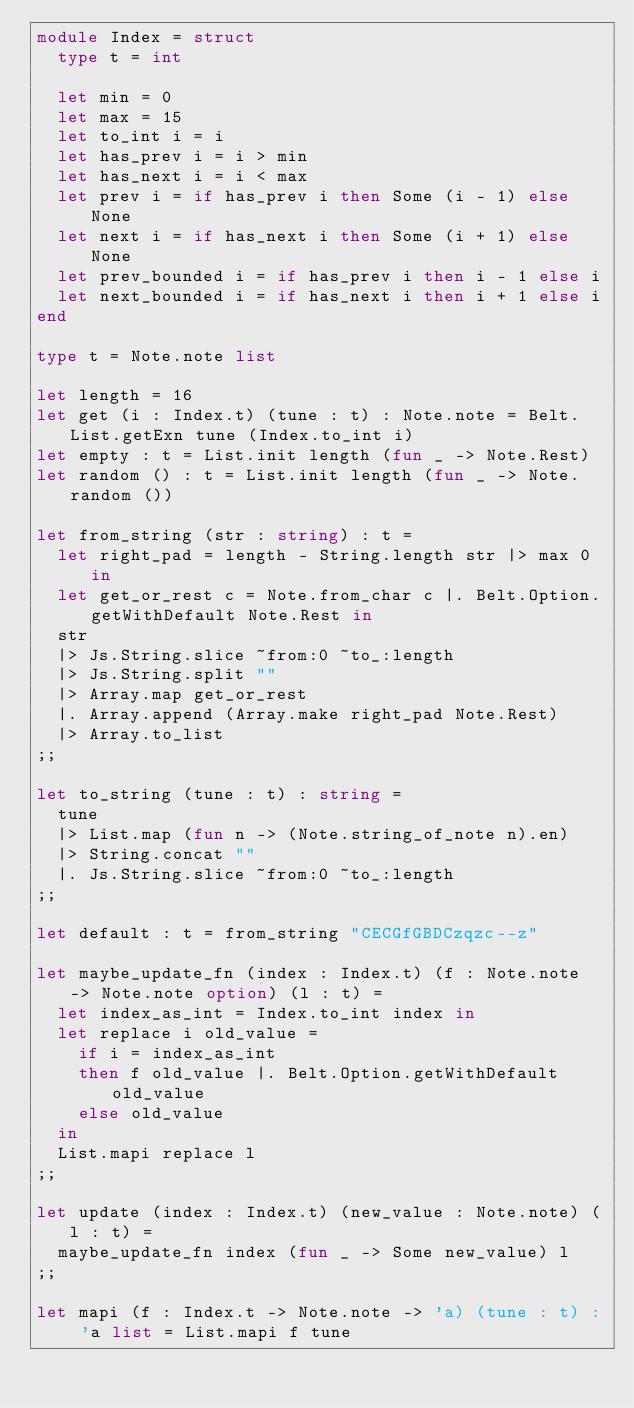Convert code to text. <code><loc_0><loc_0><loc_500><loc_500><_OCaml_>module Index = struct
  type t = int

  let min = 0
  let max = 15
  let to_int i = i
  let has_prev i = i > min
  let has_next i = i < max
  let prev i = if has_prev i then Some (i - 1) else None
  let next i = if has_next i then Some (i + 1) else None
  let prev_bounded i = if has_prev i then i - 1 else i
  let next_bounded i = if has_next i then i + 1 else i
end

type t = Note.note list

let length = 16
let get (i : Index.t) (tune : t) : Note.note = Belt.List.getExn tune (Index.to_int i)
let empty : t = List.init length (fun _ -> Note.Rest)
let random () : t = List.init length (fun _ -> Note.random ())

let from_string (str : string) : t =
  let right_pad = length - String.length str |> max 0 in
  let get_or_rest c = Note.from_char c |. Belt.Option.getWithDefault Note.Rest in
  str
  |> Js.String.slice ~from:0 ~to_:length
  |> Js.String.split ""
  |> Array.map get_or_rest
  |. Array.append (Array.make right_pad Note.Rest)
  |> Array.to_list
;;

let to_string (tune : t) : string =
  tune
  |> List.map (fun n -> (Note.string_of_note n).en)
  |> String.concat ""
  |. Js.String.slice ~from:0 ~to_:length
;;

let default : t = from_string "CECGfGBDCzqzc--z"

let maybe_update_fn (index : Index.t) (f : Note.note -> Note.note option) (l : t) =
  let index_as_int = Index.to_int index in
  let replace i old_value =
    if i = index_as_int
    then f old_value |. Belt.Option.getWithDefault old_value
    else old_value
  in
  List.mapi replace l
;;

let update (index : Index.t) (new_value : Note.note) (l : t) =
  maybe_update_fn index (fun _ -> Some new_value) l
;;

let mapi (f : Index.t -> Note.note -> 'a) (tune : t) : 'a list = List.mapi f tune
</code> 